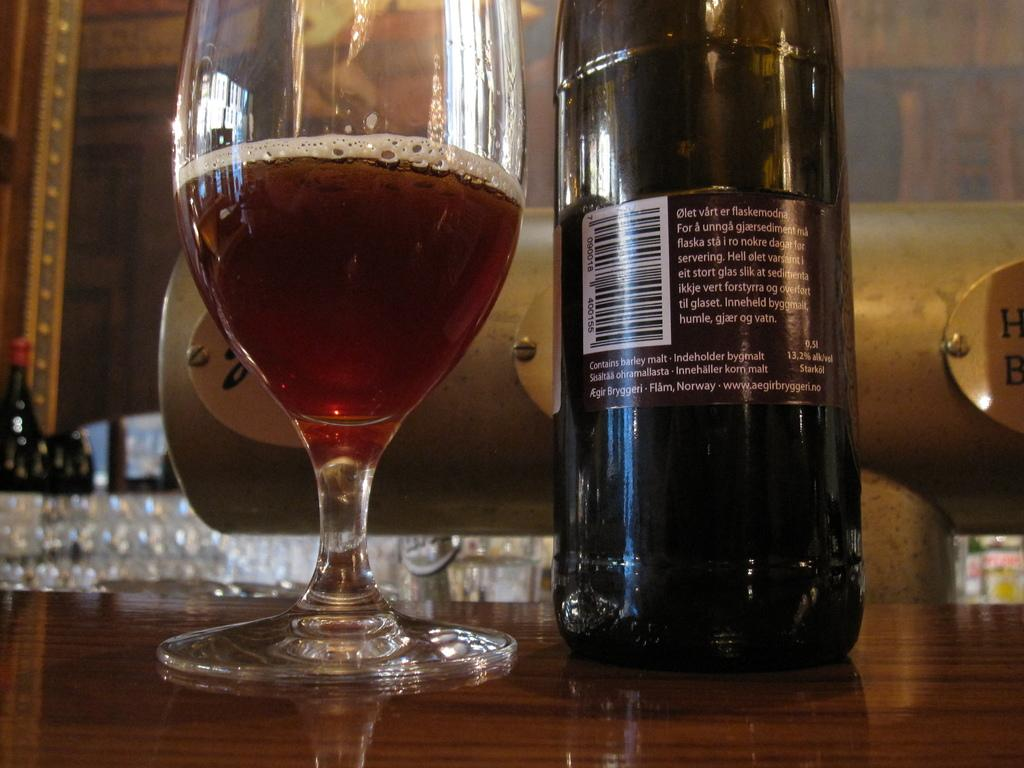<image>
Present a compact description of the photo's key features. The back label of a bottle of wine from Norway 